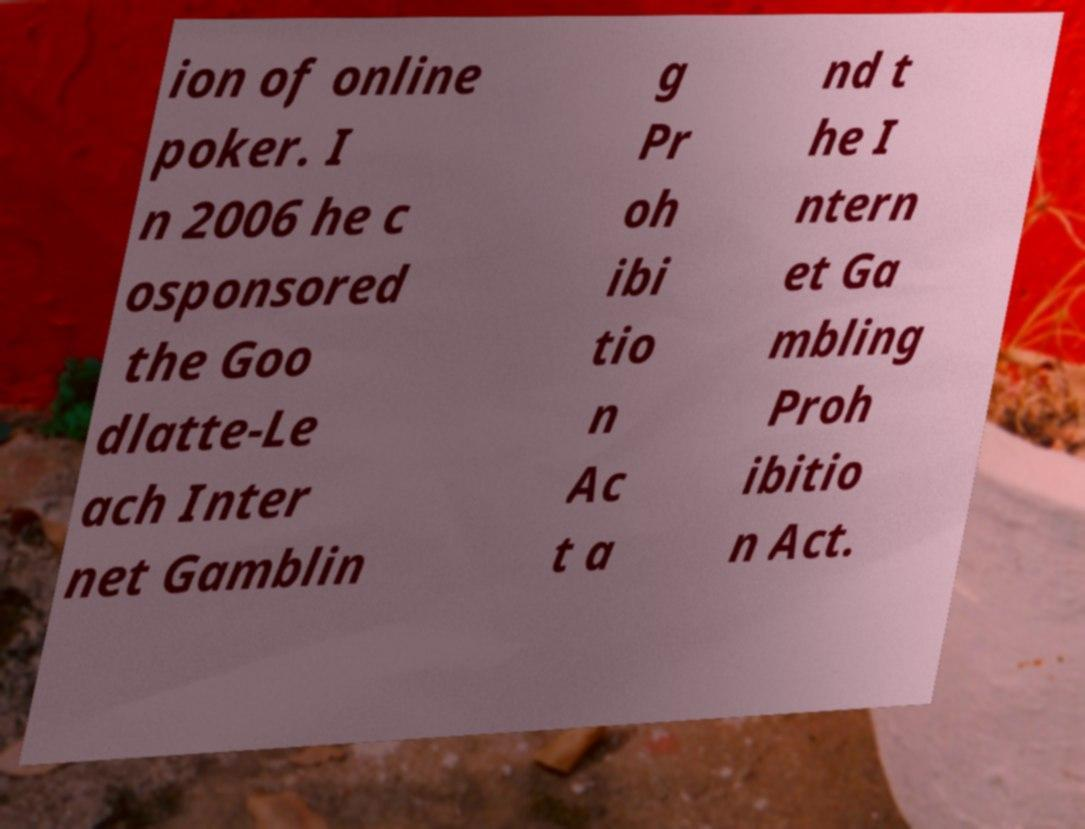Could you extract and type out the text from this image? ion of online poker. I n 2006 he c osponsored the Goo dlatte-Le ach Inter net Gamblin g Pr oh ibi tio n Ac t a nd t he I ntern et Ga mbling Proh ibitio n Act. 